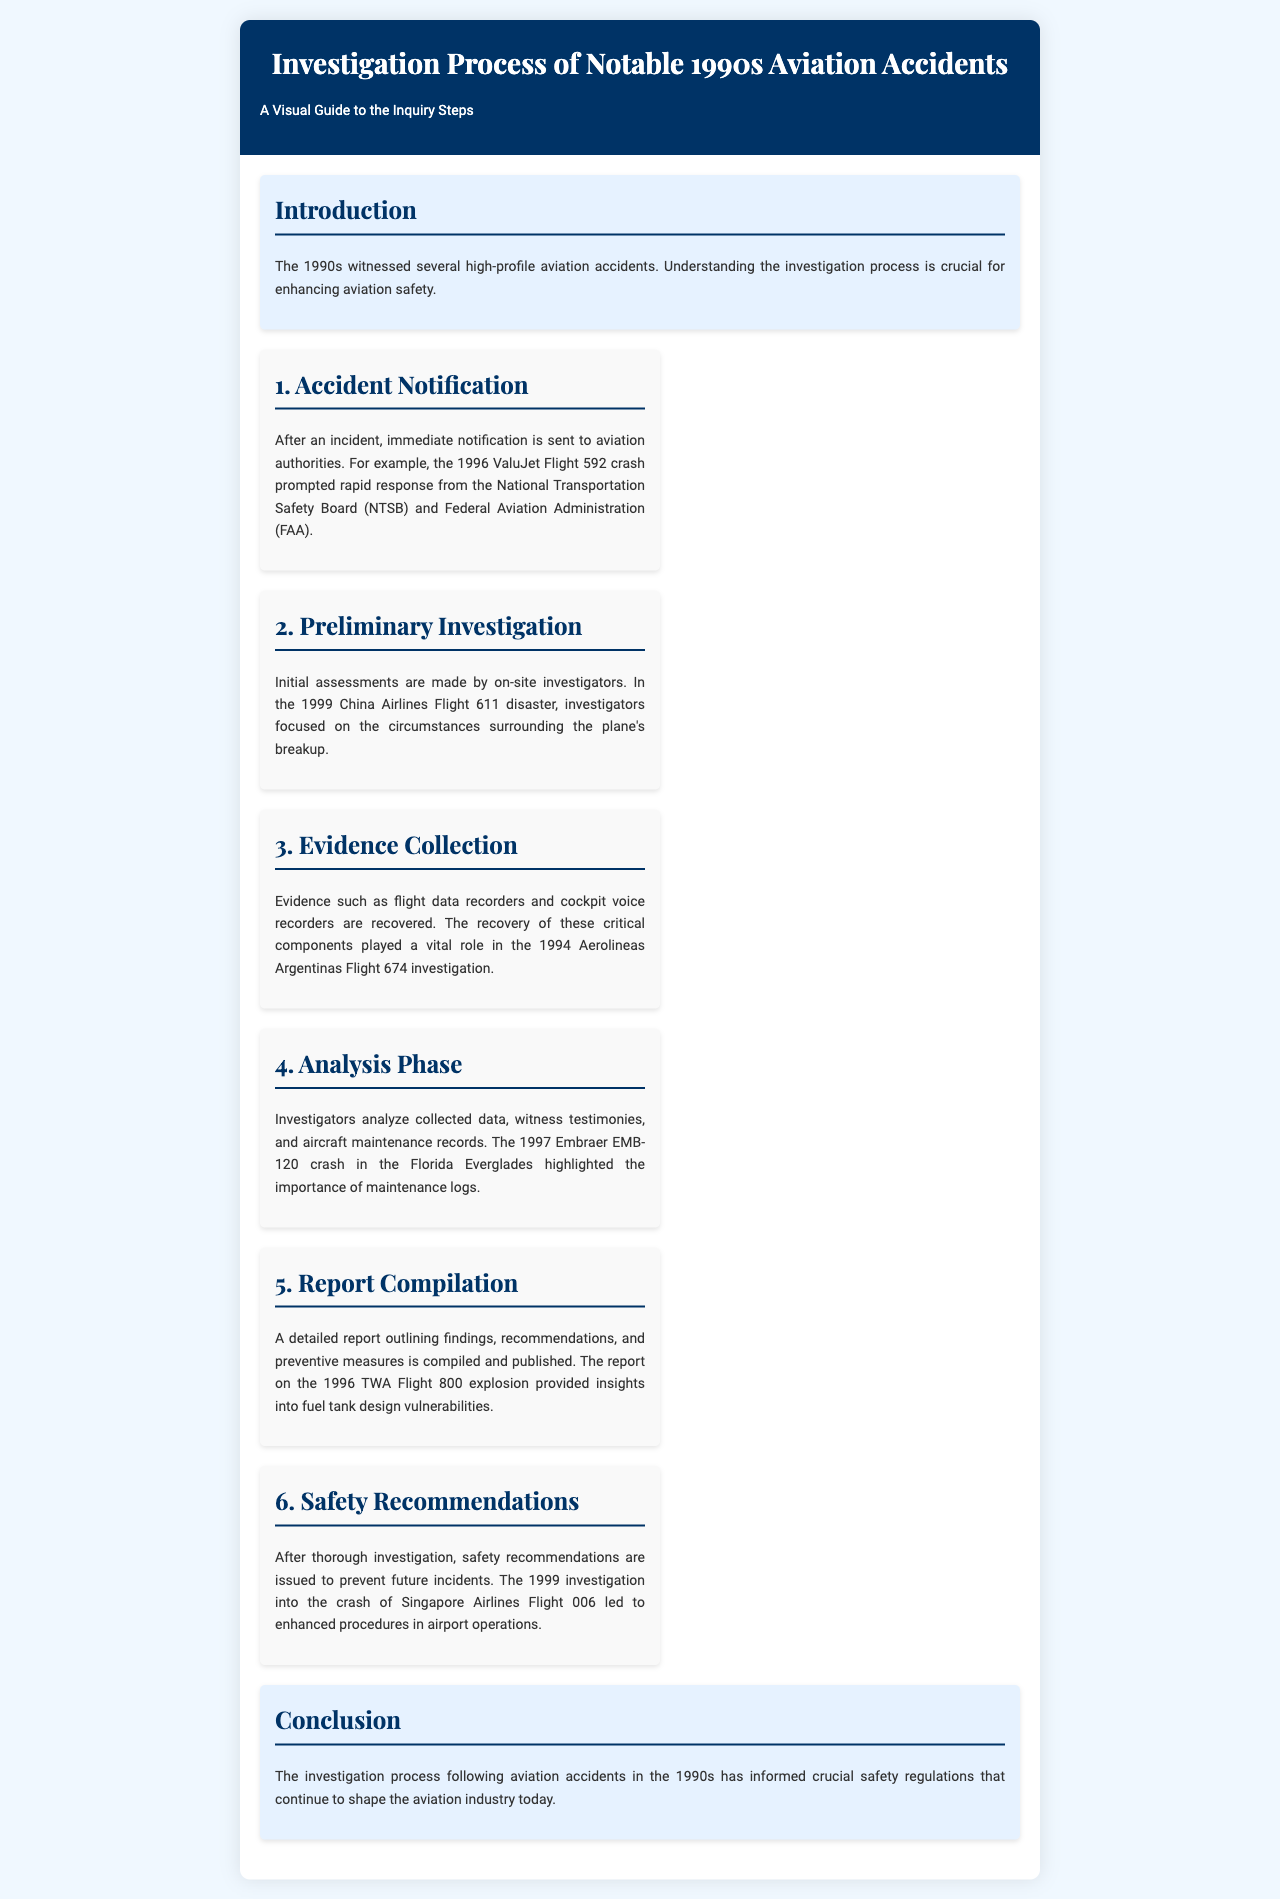What is the title of the brochure? The title is the main heading presented in the document's header section.
Answer: Investigation Process of Notable 1990s Aviation Accidents How many steps are detailed in the investigation process? The document lists the major steps of the investigation process numerically in six sections.
Answer: 6 Which flight crash prompted rapid response from the NTSB and FAA? The document specifies an example that illustrates this notification step in the investigation process.
Answer: ValuJet Flight 592 What year did the Embraer EMB-120 crash occur? The document provides a specific incident date associated with a key investigation phase.
Answer: 1997 What did the investigation of the 1994 Aerolineas Argentinas Flight 674 focus on? This is related to an example of evidence collection in the document.
Answer: Flight data recorders and cockpit voice recorders What type of recommendations are issued after an investigation? The text describes the outcome of the final investigation phase, indicating the nature of recommendations given.
Answer: Safety recommendations Which accident investigation highlighted maintenance logs' importance? The document mentions a specific crash as an example in the analysis phase.
Answer: Embraer EMB-120 crash What did the report on the 1996 TWA Flight 800 explosion provide insights into? This concerns the content of a report compiled after an investigation, as cited in the document.
Answer: Fuel tank design vulnerabilities 